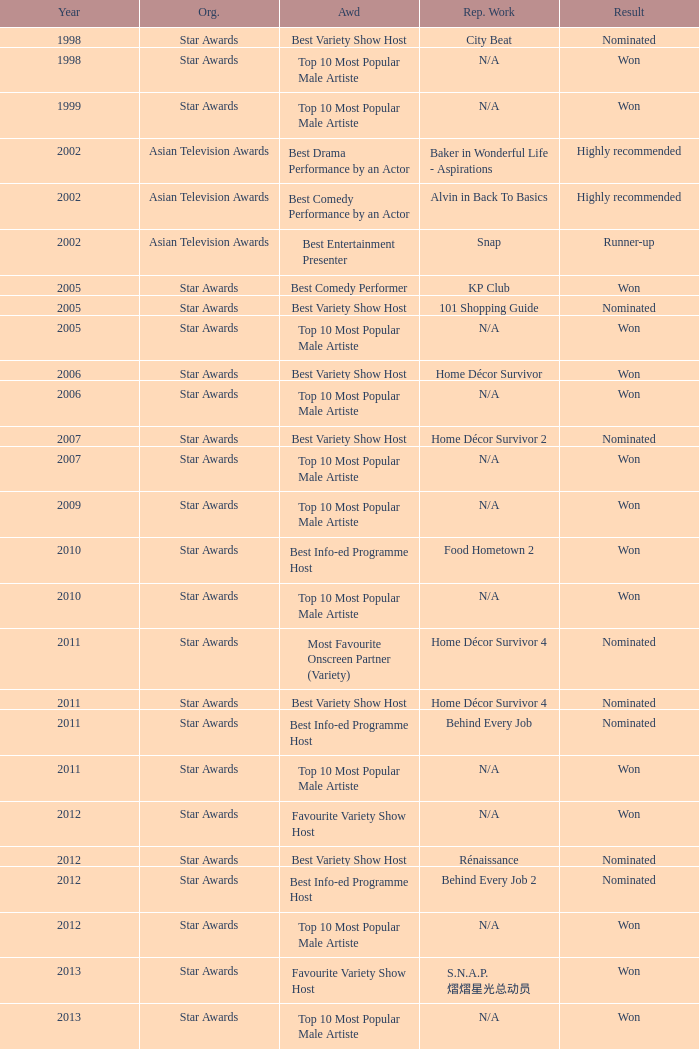What is the name of the Representative Work in a year later than 2005 with a Result of nominated, and an Award of best variety show host? Home Décor Survivor 2, Home Décor Survivor 4, Rénaissance, Jobs Around The World. 